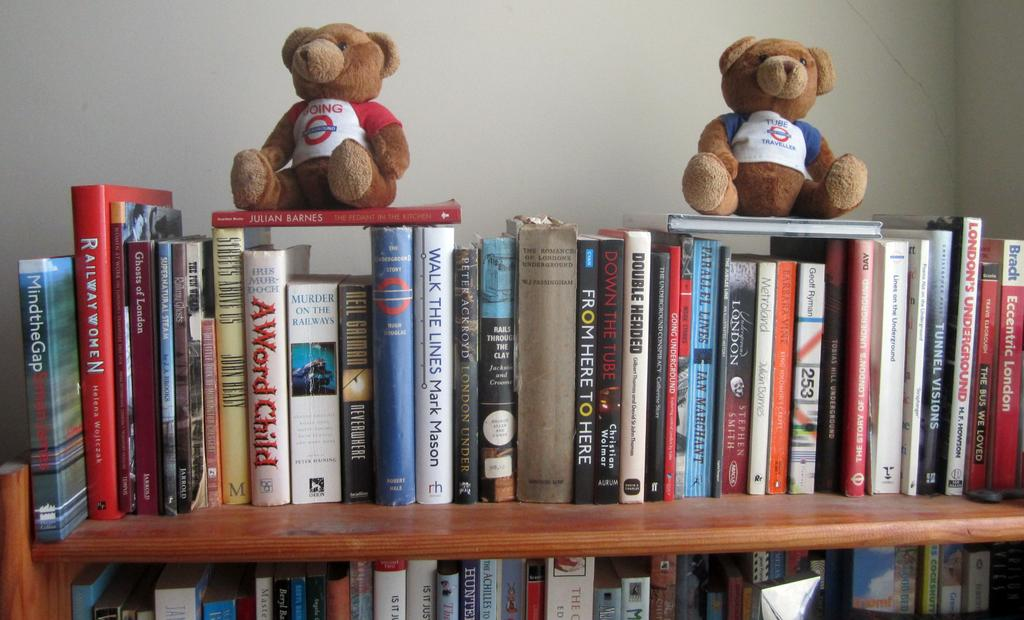What type of stuffed animals are in the image? There are two teddy bears in the image. What can be seen on the rack in the image? There are books on a rack in the image. What is visible in the background of the image? There is a wall in the background of the image. How many rooms are visible in the image? There is no room visible in the image; it only shows teddy bears, books, and a wall. What level of comfort do the teddy bears provide in the image? The level of comfort provided by the teddy bears cannot be determined from the image alone. 